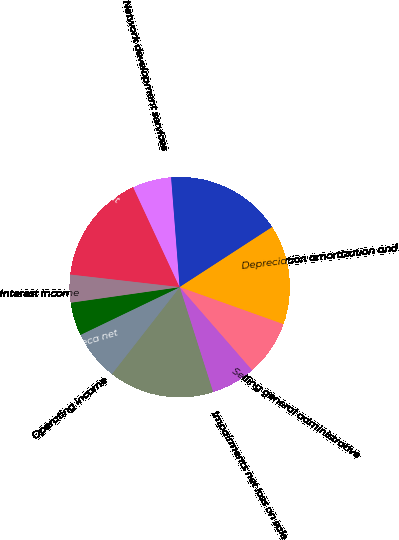Convert chart. <chart><loc_0><loc_0><loc_500><loc_500><pie_chart><fcel>Rental and management<fcel>Network development services<fcel>Total operating revenues<fcel>Depreciation amortization and<fcel>Selling general administrative<fcel>Impairments net loss on sale<fcel>Total operating expenses<fcel>Operating income<fcel>Interest income TV Azteca net<fcel>Interest income<nl><fcel>16.26%<fcel>5.69%<fcel>17.07%<fcel>14.63%<fcel>8.13%<fcel>6.5%<fcel>15.45%<fcel>7.32%<fcel>4.88%<fcel>4.07%<nl></chart> 